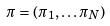Convert formula to latex. <formula><loc_0><loc_0><loc_500><loc_500>\pi = ( \pi _ { 1 } , \dots \pi _ { N } )</formula> 